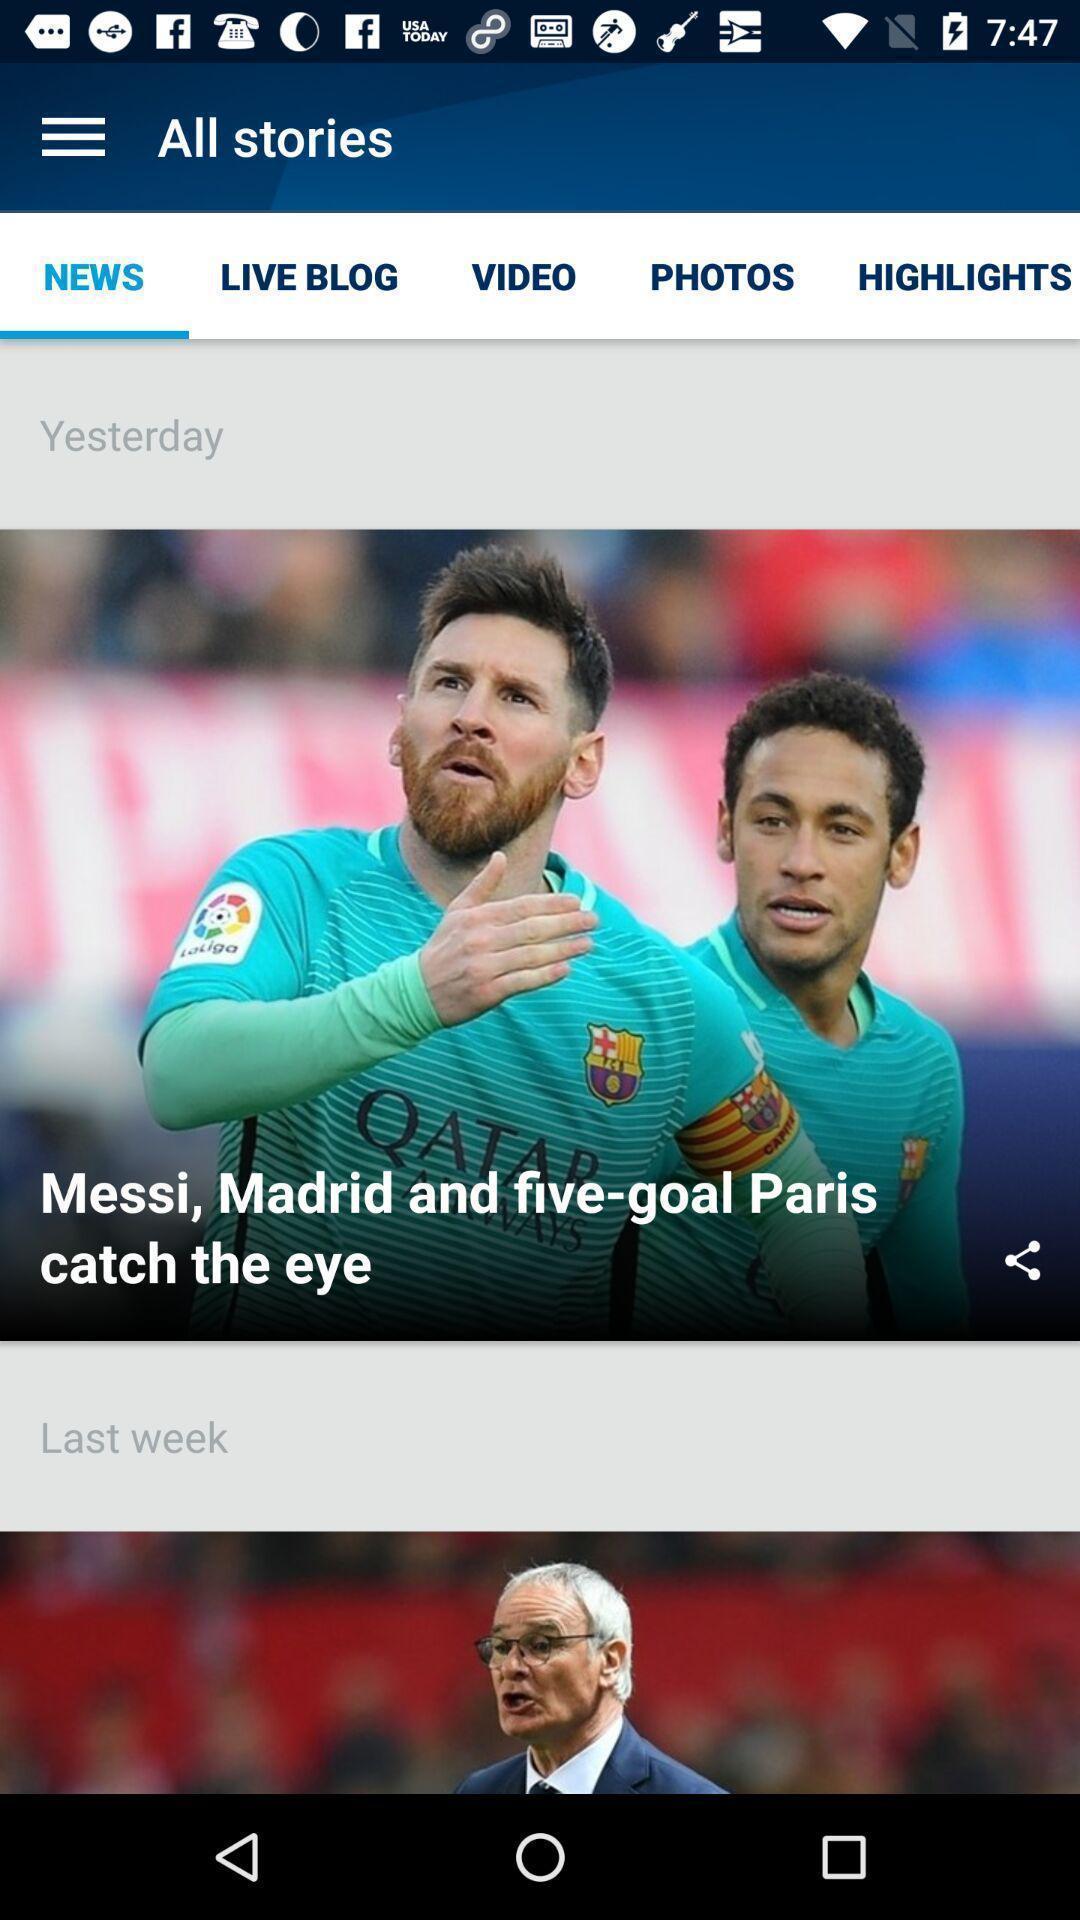What is the overall content of this screenshot? Sport app displaying news page and other options. 